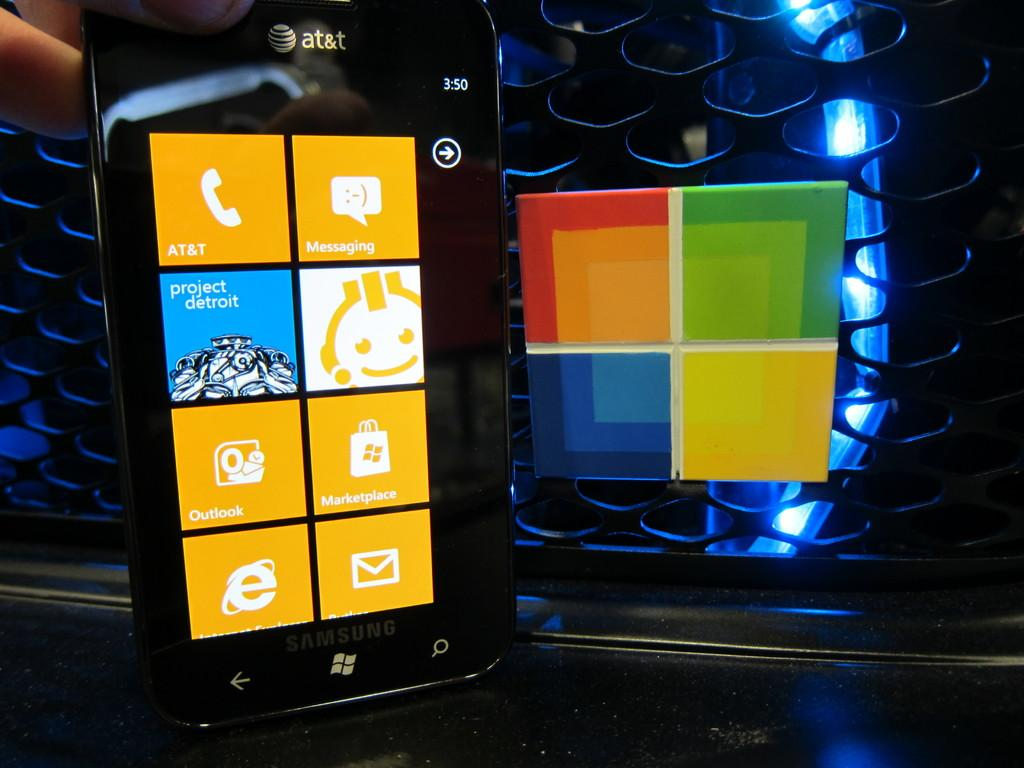<image>
Provide a brief description of the given image. An At&T phone with 8 aps showing on the screen. 